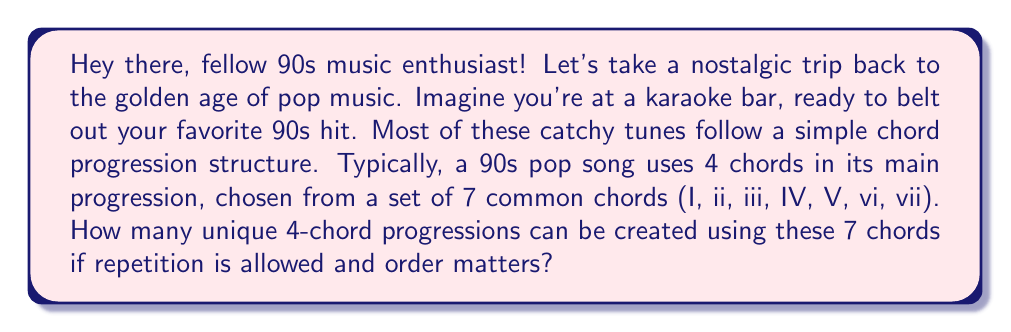Solve this math problem. Let's break this down step-by-step, just like we'd analyze the structure of our favorite 90s pop song:

1) We're dealing with a problem of permutation with repetition. This is because:
   - We're selecting 4 chords (the length of our progression)
   - We're selecting from 7 possible chords
   - We can repeat chords (e.g., I-V-V-vi is a valid progression)
   - The order matters (I-V-vi-IV sounds different from IV-vi-V-I)

2) In permutation with repetition, the formula is:

   $$ n^r $$

   Where $n$ is the number of items to choose from, and $r$ is the number of selections.

3) In our case:
   $n = 7$ (the number of possible chords)
   $r = 4$ (the length of our chord progression)

4) Plugging these values into our formula:

   $$ 7^4 $$

5) Let's calculate this:
   $$ 7^4 = 7 \times 7 \times 7 \times 7 = 2401 $$

So, just like how the 90s gave us an explosion of pop music variety, we have 2401 possible chord progressions to work with!
Answer: $$ 7^4 = 2401 $$ 